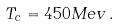<formula> <loc_0><loc_0><loc_500><loc_500>T _ { c } = 4 5 0 M e v \, .</formula> 